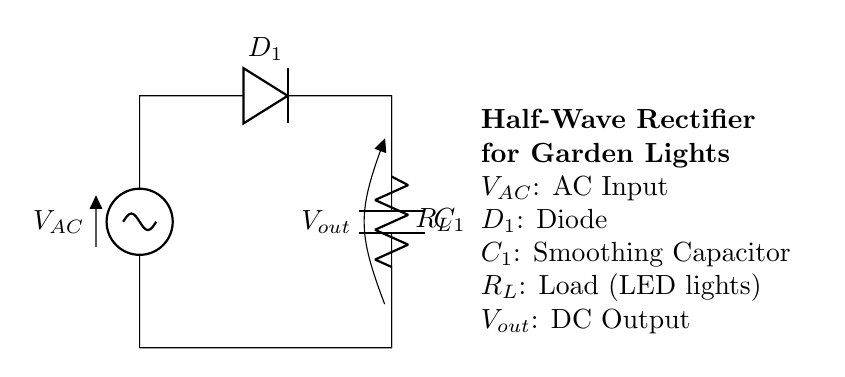What is the type of input voltage for this circuit? The input voltage is labeled as AC, which indicates that it is alternating current. This is typically used in household or garden lighting applications.
Answer: AC What component smooths the output voltage? The component labeled as C1 is a smoothing capacitor. It stores charge and helps to reduce voltage fluctuations in the output, providing a more stable DC voltage for the load.
Answer: C1 What is the purpose of the diode in this circuit? The diode labeled D1 allows current to flow in one direction only, which is essential for the rectification process. It converts the AC input into pulsating DC, supplying the load with the necessary electrical current.
Answer: D1 What is the load in this half-wave rectifier circuit? The load is represented by R_L, which is the resistance connected to the output. In this scenario, it typically powers low-voltage garden lights such as LED lights.
Answer: R_L What happens to the voltage after the diode? After passing through the diode, the output voltage becomes pulsating DC. The diode blocks the negative half-cycles of the AC, allowing only the positive half-cycles to pass, resulting in a DC voltage at the output.
Answer: Pulsating DC How does the capacitor contribute to the circuit’s function? The capacitor C1 charges during the positive half-cycles of the input signal and discharges slowly, which helps smooth the output voltage by reducing ripple, providing a steadier supply to the load.
Answer: Smooths output 